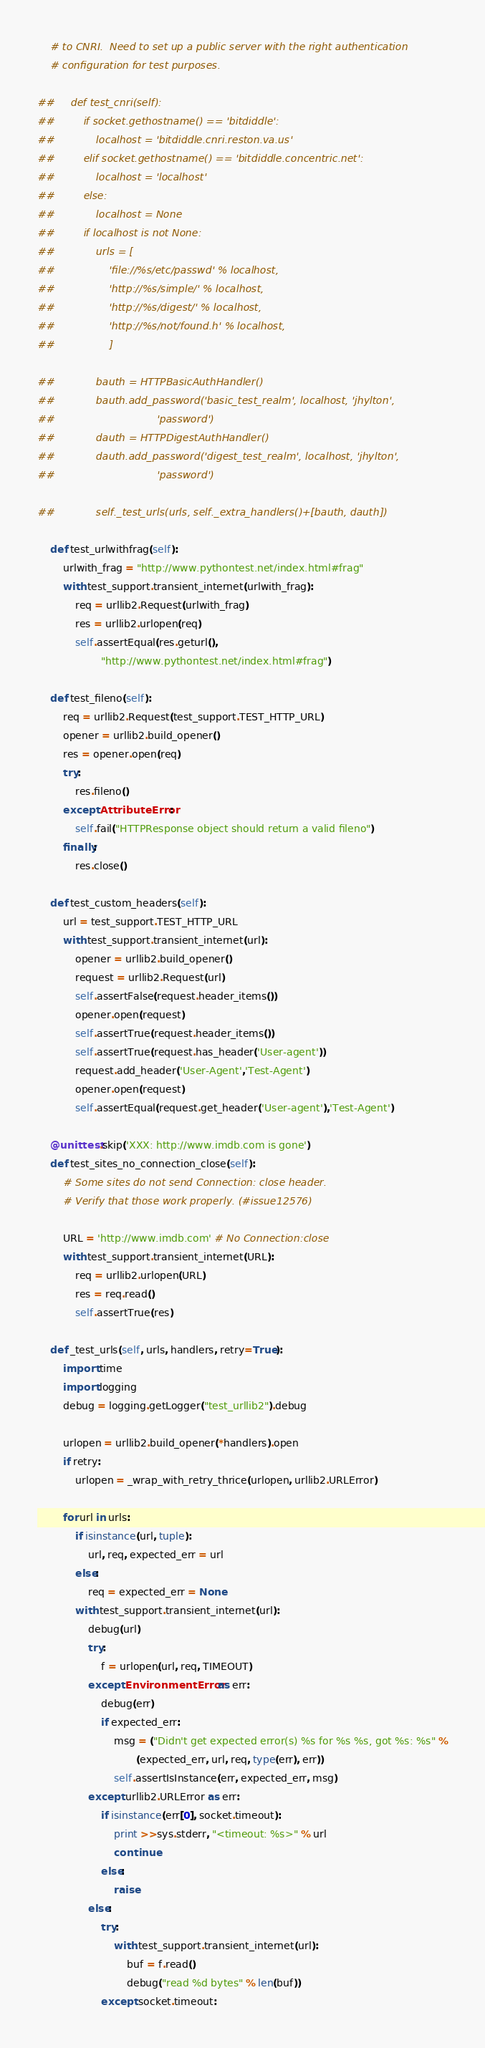Convert code to text. <code><loc_0><loc_0><loc_500><loc_500><_Python_>    # to CNRI.  Need to set up a public server with the right authentication
    # configuration for test purposes.

##     def test_cnri(self):
##         if socket.gethostname() == 'bitdiddle':
##             localhost = 'bitdiddle.cnri.reston.va.us'
##         elif socket.gethostname() == 'bitdiddle.concentric.net':
##             localhost = 'localhost'
##         else:
##             localhost = None
##         if localhost is not None:
##             urls = [
##                 'file://%s/etc/passwd' % localhost,
##                 'http://%s/simple/' % localhost,
##                 'http://%s/digest/' % localhost,
##                 'http://%s/not/found.h' % localhost,
##                 ]

##             bauth = HTTPBasicAuthHandler()
##             bauth.add_password('basic_test_realm', localhost, 'jhylton',
##                                'password')
##             dauth = HTTPDigestAuthHandler()
##             dauth.add_password('digest_test_realm', localhost, 'jhylton',
##                                'password')

##             self._test_urls(urls, self._extra_handlers()+[bauth, dauth])

    def test_urlwithfrag(self):
        urlwith_frag = "http://www.pythontest.net/index.html#frag"
        with test_support.transient_internet(urlwith_frag):
            req = urllib2.Request(urlwith_frag)
            res = urllib2.urlopen(req)
            self.assertEqual(res.geturl(),
                    "http://www.pythontest.net/index.html#frag")

    def test_fileno(self):
        req = urllib2.Request(test_support.TEST_HTTP_URL)
        opener = urllib2.build_opener()
        res = opener.open(req)
        try:
            res.fileno()
        except AttributeError:
            self.fail("HTTPResponse object should return a valid fileno")
        finally:
            res.close()

    def test_custom_headers(self):
        url = test_support.TEST_HTTP_URL
        with test_support.transient_internet(url):
            opener = urllib2.build_opener()
            request = urllib2.Request(url)
            self.assertFalse(request.header_items())
            opener.open(request)
            self.assertTrue(request.header_items())
            self.assertTrue(request.has_header('User-agent'))
            request.add_header('User-Agent','Test-Agent')
            opener.open(request)
            self.assertEqual(request.get_header('User-agent'),'Test-Agent')

    @unittest.skip('XXX: http://www.imdb.com is gone')
    def test_sites_no_connection_close(self):
        # Some sites do not send Connection: close header.
        # Verify that those work properly. (#issue12576)

        URL = 'http://www.imdb.com' # No Connection:close
        with test_support.transient_internet(URL):
            req = urllib2.urlopen(URL)
            res = req.read()
            self.assertTrue(res)

    def _test_urls(self, urls, handlers, retry=True):
        import time
        import logging
        debug = logging.getLogger("test_urllib2").debug

        urlopen = urllib2.build_opener(*handlers).open
        if retry:
            urlopen = _wrap_with_retry_thrice(urlopen, urllib2.URLError)

        for url in urls:
            if isinstance(url, tuple):
                url, req, expected_err = url
            else:
                req = expected_err = None
            with test_support.transient_internet(url):
                debug(url)
                try:
                    f = urlopen(url, req, TIMEOUT)
                except EnvironmentError as err:
                    debug(err)
                    if expected_err:
                        msg = ("Didn't get expected error(s) %s for %s %s, got %s: %s" %
                               (expected_err, url, req, type(err), err))
                        self.assertIsInstance(err, expected_err, msg)
                except urllib2.URLError as err:
                    if isinstance(err[0], socket.timeout):
                        print >>sys.stderr, "<timeout: %s>" % url
                        continue
                    else:
                        raise
                else:
                    try:
                        with test_support.transient_internet(url):
                            buf = f.read()
                            debug("read %d bytes" % len(buf))
                    except socket.timeout:</code> 